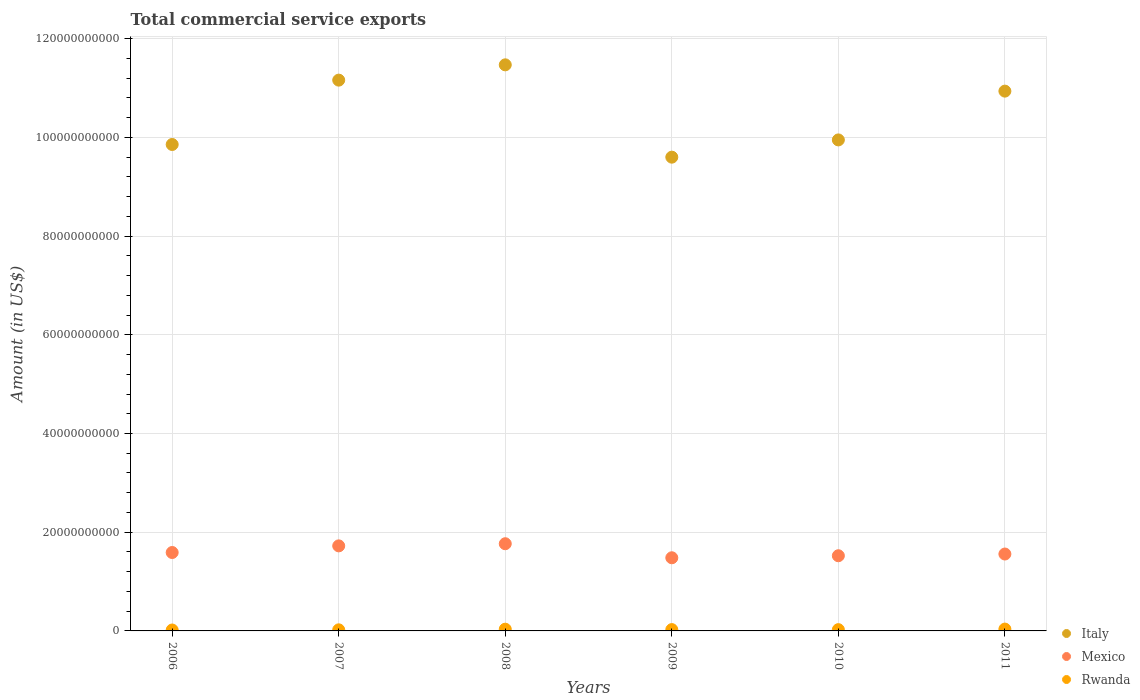What is the total commercial service exports in Mexico in 2010?
Provide a short and direct response. 1.52e+1. Across all years, what is the maximum total commercial service exports in Italy?
Make the answer very short. 1.15e+11. Across all years, what is the minimum total commercial service exports in Rwanda?
Make the answer very short. 1.87e+08. In which year was the total commercial service exports in Rwanda minimum?
Your response must be concise. 2006. What is the total total commercial service exports in Italy in the graph?
Keep it short and to the point. 6.30e+11. What is the difference between the total commercial service exports in Mexico in 2008 and that in 2009?
Your answer should be very brief. 2.85e+09. What is the difference between the total commercial service exports in Rwanda in 2010 and the total commercial service exports in Mexico in 2008?
Give a very brief answer. -1.74e+1. What is the average total commercial service exports in Italy per year?
Give a very brief answer. 1.05e+11. In the year 2009, what is the difference between the total commercial service exports in Rwanda and total commercial service exports in Italy?
Offer a terse response. -9.57e+1. What is the ratio of the total commercial service exports in Italy in 2006 to that in 2011?
Give a very brief answer. 0.9. What is the difference between the highest and the second highest total commercial service exports in Italy?
Provide a succinct answer. 3.10e+09. What is the difference between the highest and the lowest total commercial service exports in Rwanda?
Offer a terse response. 1.86e+08. Is the sum of the total commercial service exports in Mexico in 2008 and 2011 greater than the maximum total commercial service exports in Rwanda across all years?
Provide a short and direct response. Yes. Does the total commercial service exports in Rwanda monotonically increase over the years?
Give a very brief answer. No. Is the total commercial service exports in Rwanda strictly greater than the total commercial service exports in Mexico over the years?
Ensure brevity in your answer.  No. Is the total commercial service exports in Italy strictly less than the total commercial service exports in Mexico over the years?
Provide a short and direct response. No. How many dotlines are there?
Provide a succinct answer. 3. How many years are there in the graph?
Keep it short and to the point. 6. What is the difference between two consecutive major ticks on the Y-axis?
Your answer should be very brief. 2.00e+1. How many legend labels are there?
Ensure brevity in your answer.  3. What is the title of the graph?
Your answer should be compact. Total commercial service exports. Does "Kuwait" appear as one of the legend labels in the graph?
Provide a succinct answer. No. What is the Amount (in US$) in Italy in 2006?
Offer a terse response. 9.86e+1. What is the Amount (in US$) in Mexico in 2006?
Your answer should be compact. 1.59e+1. What is the Amount (in US$) in Rwanda in 2006?
Your answer should be very brief. 1.87e+08. What is the Amount (in US$) in Italy in 2007?
Make the answer very short. 1.12e+11. What is the Amount (in US$) of Mexico in 2007?
Provide a short and direct response. 1.72e+1. What is the Amount (in US$) of Rwanda in 2007?
Provide a succinct answer. 2.22e+08. What is the Amount (in US$) of Italy in 2008?
Provide a succinct answer. 1.15e+11. What is the Amount (in US$) of Mexico in 2008?
Offer a very short reply. 1.77e+1. What is the Amount (in US$) of Rwanda in 2008?
Ensure brevity in your answer.  3.51e+08. What is the Amount (in US$) in Italy in 2009?
Your answer should be very brief. 9.60e+1. What is the Amount (in US$) of Mexico in 2009?
Ensure brevity in your answer.  1.48e+1. What is the Amount (in US$) of Rwanda in 2009?
Ensure brevity in your answer.  2.69e+08. What is the Amount (in US$) in Italy in 2010?
Make the answer very short. 9.95e+1. What is the Amount (in US$) in Mexico in 2010?
Offer a very short reply. 1.52e+1. What is the Amount (in US$) of Rwanda in 2010?
Make the answer very short. 2.59e+08. What is the Amount (in US$) of Italy in 2011?
Give a very brief answer. 1.09e+11. What is the Amount (in US$) of Mexico in 2011?
Make the answer very short. 1.56e+1. What is the Amount (in US$) in Rwanda in 2011?
Provide a succinct answer. 3.73e+08. Across all years, what is the maximum Amount (in US$) in Italy?
Keep it short and to the point. 1.15e+11. Across all years, what is the maximum Amount (in US$) in Mexico?
Ensure brevity in your answer.  1.77e+1. Across all years, what is the maximum Amount (in US$) in Rwanda?
Provide a succinct answer. 3.73e+08. Across all years, what is the minimum Amount (in US$) of Italy?
Your answer should be compact. 9.60e+1. Across all years, what is the minimum Amount (in US$) of Mexico?
Offer a terse response. 1.48e+1. Across all years, what is the minimum Amount (in US$) of Rwanda?
Provide a succinct answer. 1.87e+08. What is the total Amount (in US$) of Italy in the graph?
Offer a terse response. 6.30e+11. What is the total Amount (in US$) in Mexico in the graph?
Offer a very short reply. 9.64e+1. What is the total Amount (in US$) of Rwanda in the graph?
Make the answer very short. 1.66e+09. What is the difference between the Amount (in US$) of Italy in 2006 and that in 2007?
Offer a terse response. -1.30e+1. What is the difference between the Amount (in US$) in Mexico in 2006 and that in 2007?
Provide a succinct answer. -1.35e+09. What is the difference between the Amount (in US$) in Rwanda in 2006 and that in 2007?
Offer a terse response. -3.54e+07. What is the difference between the Amount (in US$) of Italy in 2006 and that in 2008?
Offer a terse response. -1.61e+1. What is the difference between the Amount (in US$) in Mexico in 2006 and that in 2008?
Ensure brevity in your answer.  -1.78e+09. What is the difference between the Amount (in US$) in Rwanda in 2006 and that in 2008?
Offer a very short reply. -1.64e+08. What is the difference between the Amount (in US$) in Italy in 2006 and that in 2009?
Make the answer very short. 2.57e+09. What is the difference between the Amount (in US$) of Mexico in 2006 and that in 2009?
Keep it short and to the point. 1.07e+09. What is the difference between the Amount (in US$) of Rwanda in 2006 and that in 2009?
Your answer should be very brief. -8.28e+07. What is the difference between the Amount (in US$) of Italy in 2006 and that in 2010?
Ensure brevity in your answer.  -9.27e+08. What is the difference between the Amount (in US$) in Mexico in 2006 and that in 2010?
Give a very brief answer. 6.55e+08. What is the difference between the Amount (in US$) in Rwanda in 2006 and that in 2010?
Your response must be concise. -7.28e+07. What is the difference between the Amount (in US$) in Italy in 2006 and that in 2011?
Make the answer very short. -1.08e+1. What is the difference between the Amount (in US$) in Mexico in 2006 and that in 2011?
Ensure brevity in your answer.  3.07e+08. What is the difference between the Amount (in US$) of Rwanda in 2006 and that in 2011?
Your answer should be compact. -1.86e+08. What is the difference between the Amount (in US$) in Italy in 2007 and that in 2008?
Give a very brief answer. -3.10e+09. What is the difference between the Amount (in US$) of Mexico in 2007 and that in 2008?
Ensure brevity in your answer.  -4.34e+08. What is the difference between the Amount (in US$) of Rwanda in 2007 and that in 2008?
Provide a succinct answer. -1.29e+08. What is the difference between the Amount (in US$) in Italy in 2007 and that in 2009?
Keep it short and to the point. 1.56e+1. What is the difference between the Amount (in US$) of Mexico in 2007 and that in 2009?
Make the answer very short. 2.41e+09. What is the difference between the Amount (in US$) in Rwanda in 2007 and that in 2009?
Offer a terse response. -4.74e+07. What is the difference between the Amount (in US$) in Italy in 2007 and that in 2010?
Provide a succinct answer. 1.21e+1. What is the difference between the Amount (in US$) of Mexico in 2007 and that in 2010?
Your answer should be compact. 2.00e+09. What is the difference between the Amount (in US$) in Rwanda in 2007 and that in 2010?
Keep it short and to the point. -3.73e+07. What is the difference between the Amount (in US$) of Italy in 2007 and that in 2011?
Make the answer very short. 2.23e+09. What is the difference between the Amount (in US$) of Mexico in 2007 and that in 2011?
Provide a succinct answer. 1.65e+09. What is the difference between the Amount (in US$) in Rwanda in 2007 and that in 2011?
Keep it short and to the point. -1.51e+08. What is the difference between the Amount (in US$) in Italy in 2008 and that in 2009?
Your response must be concise. 1.87e+1. What is the difference between the Amount (in US$) of Mexico in 2008 and that in 2009?
Keep it short and to the point. 2.85e+09. What is the difference between the Amount (in US$) of Rwanda in 2008 and that in 2009?
Keep it short and to the point. 8.14e+07. What is the difference between the Amount (in US$) of Italy in 2008 and that in 2010?
Make the answer very short. 1.52e+1. What is the difference between the Amount (in US$) in Mexico in 2008 and that in 2010?
Offer a very short reply. 2.43e+09. What is the difference between the Amount (in US$) of Rwanda in 2008 and that in 2010?
Give a very brief answer. 9.14e+07. What is the difference between the Amount (in US$) of Italy in 2008 and that in 2011?
Offer a terse response. 5.33e+09. What is the difference between the Amount (in US$) of Mexico in 2008 and that in 2011?
Keep it short and to the point. 2.09e+09. What is the difference between the Amount (in US$) of Rwanda in 2008 and that in 2011?
Give a very brief answer. -2.21e+07. What is the difference between the Amount (in US$) of Italy in 2009 and that in 2010?
Provide a short and direct response. -3.49e+09. What is the difference between the Amount (in US$) of Mexico in 2009 and that in 2010?
Provide a short and direct response. -4.12e+08. What is the difference between the Amount (in US$) of Rwanda in 2009 and that in 2010?
Provide a succinct answer. 1.00e+07. What is the difference between the Amount (in US$) in Italy in 2009 and that in 2011?
Keep it short and to the point. -1.34e+1. What is the difference between the Amount (in US$) of Mexico in 2009 and that in 2011?
Give a very brief answer. -7.60e+08. What is the difference between the Amount (in US$) of Rwanda in 2009 and that in 2011?
Your answer should be compact. -1.04e+08. What is the difference between the Amount (in US$) of Italy in 2010 and that in 2011?
Provide a succinct answer. -9.89e+09. What is the difference between the Amount (in US$) in Mexico in 2010 and that in 2011?
Provide a succinct answer. -3.48e+08. What is the difference between the Amount (in US$) in Rwanda in 2010 and that in 2011?
Ensure brevity in your answer.  -1.14e+08. What is the difference between the Amount (in US$) of Italy in 2006 and the Amount (in US$) of Mexico in 2007?
Provide a short and direct response. 8.13e+1. What is the difference between the Amount (in US$) in Italy in 2006 and the Amount (in US$) in Rwanda in 2007?
Keep it short and to the point. 9.83e+1. What is the difference between the Amount (in US$) of Mexico in 2006 and the Amount (in US$) of Rwanda in 2007?
Your answer should be very brief. 1.57e+1. What is the difference between the Amount (in US$) of Italy in 2006 and the Amount (in US$) of Mexico in 2008?
Keep it short and to the point. 8.09e+1. What is the difference between the Amount (in US$) in Italy in 2006 and the Amount (in US$) in Rwanda in 2008?
Ensure brevity in your answer.  9.82e+1. What is the difference between the Amount (in US$) in Mexico in 2006 and the Amount (in US$) in Rwanda in 2008?
Your answer should be compact. 1.55e+1. What is the difference between the Amount (in US$) in Italy in 2006 and the Amount (in US$) in Mexico in 2009?
Your response must be concise. 8.37e+1. What is the difference between the Amount (in US$) of Italy in 2006 and the Amount (in US$) of Rwanda in 2009?
Give a very brief answer. 9.83e+1. What is the difference between the Amount (in US$) in Mexico in 2006 and the Amount (in US$) in Rwanda in 2009?
Keep it short and to the point. 1.56e+1. What is the difference between the Amount (in US$) of Italy in 2006 and the Amount (in US$) of Mexico in 2010?
Your answer should be compact. 8.33e+1. What is the difference between the Amount (in US$) in Italy in 2006 and the Amount (in US$) in Rwanda in 2010?
Offer a terse response. 9.83e+1. What is the difference between the Amount (in US$) of Mexico in 2006 and the Amount (in US$) of Rwanda in 2010?
Provide a succinct answer. 1.56e+1. What is the difference between the Amount (in US$) in Italy in 2006 and the Amount (in US$) in Mexico in 2011?
Your answer should be compact. 8.30e+1. What is the difference between the Amount (in US$) of Italy in 2006 and the Amount (in US$) of Rwanda in 2011?
Provide a succinct answer. 9.82e+1. What is the difference between the Amount (in US$) of Mexico in 2006 and the Amount (in US$) of Rwanda in 2011?
Your response must be concise. 1.55e+1. What is the difference between the Amount (in US$) of Italy in 2007 and the Amount (in US$) of Mexico in 2008?
Offer a terse response. 9.39e+1. What is the difference between the Amount (in US$) of Italy in 2007 and the Amount (in US$) of Rwanda in 2008?
Make the answer very short. 1.11e+11. What is the difference between the Amount (in US$) in Mexico in 2007 and the Amount (in US$) in Rwanda in 2008?
Provide a succinct answer. 1.69e+1. What is the difference between the Amount (in US$) in Italy in 2007 and the Amount (in US$) in Mexico in 2009?
Give a very brief answer. 9.68e+1. What is the difference between the Amount (in US$) in Italy in 2007 and the Amount (in US$) in Rwanda in 2009?
Give a very brief answer. 1.11e+11. What is the difference between the Amount (in US$) in Mexico in 2007 and the Amount (in US$) in Rwanda in 2009?
Offer a terse response. 1.70e+1. What is the difference between the Amount (in US$) in Italy in 2007 and the Amount (in US$) in Mexico in 2010?
Provide a succinct answer. 9.64e+1. What is the difference between the Amount (in US$) in Italy in 2007 and the Amount (in US$) in Rwanda in 2010?
Ensure brevity in your answer.  1.11e+11. What is the difference between the Amount (in US$) of Mexico in 2007 and the Amount (in US$) of Rwanda in 2010?
Your response must be concise. 1.70e+1. What is the difference between the Amount (in US$) of Italy in 2007 and the Amount (in US$) of Mexico in 2011?
Provide a succinct answer. 9.60e+1. What is the difference between the Amount (in US$) of Italy in 2007 and the Amount (in US$) of Rwanda in 2011?
Give a very brief answer. 1.11e+11. What is the difference between the Amount (in US$) in Mexico in 2007 and the Amount (in US$) in Rwanda in 2011?
Offer a very short reply. 1.69e+1. What is the difference between the Amount (in US$) in Italy in 2008 and the Amount (in US$) in Mexico in 2009?
Keep it short and to the point. 9.99e+1. What is the difference between the Amount (in US$) of Italy in 2008 and the Amount (in US$) of Rwanda in 2009?
Your answer should be very brief. 1.14e+11. What is the difference between the Amount (in US$) of Mexico in 2008 and the Amount (in US$) of Rwanda in 2009?
Offer a very short reply. 1.74e+1. What is the difference between the Amount (in US$) of Italy in 2008 and the Amount (in US$) of Mexico in 2010?
Your answer should be compact. 9.95e+1. What is the difference between the Amount (in US$) of Italy in 2008 and the Amount (in US$) of Rwanda in 2010?
Provide a short and direct response. 1.14e+11. What is the difference between the Amount (in US$) of Mexico in 2008 and the Amount (in US$) of Rwanda in 2010?
Your response must be concise. 1.74e+1. What is the difference between the Amount (in US$) in Italy in 2008 and the Amount (in US$) in Mexico in 2011?
Provide a succinct answer. 9.91e+1. What is the difference between the Amount (in US$) in Italy in 2008 and the Amount (in US$) in Rwanda in 2011?
Your answer should be very brief. 1.14e+11. What is the difference between the Amount (in US$) in Mexico in 2008 and the Amount (in US$) in Rwanda in 2011?
Provide a short and direct response. 1.73e+1. What is the difference between the Amount (in US$) in Italy in 2009 and the Amount (in US$) in Mexico in 2010?
Provide a short and direct response. 8.08e+1. What is the difference between the Amount (in US$) in Italy in 2009 and the Amount (in US$) in Rwanda in 2010?
Your answer should be compact. 9.57e+1. What is the difference between the Amount (in US$) of Mexico in 2009 and the Amount (in US$) of Rwanda in 2010?
Provide a short and direct response. 1.46e+1. What is the difference between the Amount (in US$) in Italy in 2009 and the Amount (in US$) in Mexico in 2011?
Your answer should be very brief. 8.04e+1. What is the difference between the Amount (in US$) of Italy in 2009 and the Amount (in US$) of Rwanda in 2011?
Keep it short and to the point. 9.56e+1. What is the difference between the Amount (in US$) in Mexico in 2009 and the Amount (in US$) in Rwanda in 2011?
Provide a short and direct response. 1.44e+1. What is the difference between the Amount (in US$) in Italy in 2010 and the Amount (in US$) in Mexico in 2011?
Offer a very short reply. 8.39e+1. What is the difference between the Amount (in US$) in Italy in 2010 and the Amount (in US$) in Rwanda in 2011?
Your answer should be very brief. 9.91e+1. What is the difference between the Amount (in US$) of Mexico in 2010 and the Amount (in US$) of Rwanda in 2011?
Your answer should be compact. 1.49e+1. What is the average Amount (in US$) of Italy per year?
Your response must be concise. 1.05e+11. What is the average Amount (in US$) in Mexico per year?
Your answer should be very brief. 1.61e+1. What is the average Amount (in US$) in Rwanda per year?
Give a very brief answer. 2.77e+08. In the year 2006, what is the difference between the Amount (in US$) in Italy and Amount (in US$) in Mexico?
Ensure brevity in your answer.  8.27e+1. In the year 2006, what is the difference between the Amount (in US$) in Italy and Amount (in US$) in Rwanda?
Make the answer very short. 9.84e+1. In the year 2006, what is the difference between the Amount (in US$) of Mexico and Amount (in US$) of Rwanda?
Provide a succinct answer. 1.57e+1. In the year 2007, what is the difference between the Amount (in US$) of Italy and Amount (in US$) of Mexico?
Ensure brevity in your answer.  9.44e+1. In the year 2007, what is the difference between the Amount (in US$) of Italy and Amount (in US$) of Rwanda?
Give a very brief answer. 1.11e+11. In the year 2007, what is the difference between the Amount (in US$) of Mexico and Amount (in US$) of Rwanda?
Keep it short and to the point. 1.70e+1. In the year 2008, what is the difference between the Amount (in US$) of Italy and Amount (in US$) of Mexico?
Make the answer very short. 9.70e+1. In the year 2008, what is the difference between the Amount (in US$) of Italy and Amount (in US$) of Rwanda?
Provide a succinct answer. 1.14e+11. In the year 2008, what is the difference between the Amount (in US$) of Mexico and Amount (in US$) of Rwanda?
Your response must be concise. 1.73e+1. In the year 2009, what is the difference between the Amount (in US$) in Italy and Amount (in US$) in Mexico?
Give a very brief answer. 8.12e+1. In the year 2009, what is the difference between the Amount (in US$) in Italy and Amount (in US$) in Rwanda?
Your response must be concise. 9.57e+1. In the year 2009, what is the difference between the Amount (in US$) in Mexico and Amount (in US$) in Rwanda?
Make the answer very short. 1.46e+1. In the year 2010, what is the difference between the Amount (in US$) of Italy and Amount (in US$) of Mexico?
Your answer should be compact. 8.43e+1. In the year 2010, what is the difference between the Amount (in US$) in Italy and Amount (in US$) in Rwanda?
Make the answer very short. 9.92e+1. In the year 2010, what is the difference between the Amount (in US$) in Mexico and Amount (in US$) in Rwanda?
Provide a short and direct response. 1.50e+1. In the year 2011, what is the difference between the Amount (in US$) of Italy and Amount (in US$) of Mexico?
Keep it short and to the point. 9.38e+1. In the year 2011, what is the difference between the Amount (in US$) in Italy and Amount (in US$) in Rwanda?
Provide a short and direct response. 1.09e+11. In the year 2011, what is the difference between the Amount (in US$) of Mexico and Amount (in US$) of Rwanda?
Your response must be concise. 1.52e+1. What is the ratio of the Amount (in US$) of Italy in 2006 to that in 2007?
Your answer should be very brief. 0.88. What is the ratio of the Amount (in US$) of Mexico in 2006 to that in 2007?
Offer a very short reply. 0.92. What is the ratio of the Amount (in US$) of Rwanda in 2006 to that in 2007?
Keep it short and to the point. 0.84. What is the ratio of the Amount (in US$) in Italy in 2006 to that in 2008?
Offer a very short reply. 0.86. What is the ratio of the Amount (in US$) of Mexico in 2006 to that in 2008?
Give a very brief answer. 0.9. What is the ratio of the Amount (in US$) in Rwanda in 2006 to that in 2008?
Your response must be concise. 0.53. What is the ratio of the Amount (in US$) of Italy in 2006 to that in 2009?
Ensure brevity in your answer.  1.03. What is the ratio of the Amount (in US$) of Mexico in 2006 to that in 2009?
Your response must be concise. 1.07. What is the ratio of the Amount (in US$) of Rwanda in 2006 to that in 2009?
Ensure brevity in your answer.  0.69. What is the ratio of the Amount (in US$) of Italy in 2006 to that in 2010?
Provide a short and direct response. 0.99. What is the ratio of the Amount (in US$) of Mexico in 2006 to that in 2010?
Offer a very short reply. 1.04. What is the ratio of the Amount (in US$) in Rwanda in 2006 to that in 2010?
Keep it short and to the point. 0.72. What is the ratio of the Amount (in US$) in Italy in 2006 to that in 2011?
Provide a short and direct response. 0.9. What is the ratio of the Amount (in US$) in Mexico in 2006 to that in 2011?
Provide a succinct answer. 1.02. What is the ratio of the Amount (in US$) in Rwanda in 2006 to that in 2011?
Provide a succinct answer. 0.5. What is the ratio of the Amount (in US$) of Italy in 2007 to that in 2008?
Make the answer very short. 0.97. What is the ratio of the Amount (in US$) of Mexico in 2007 to that in 2008?
Your response must be concise. 0.98. What is the ratio of the Amount (in US$) in Rwanda in 2007 to that in 2008?
Keep it short and to the point. 0.63. What is the ratio of the Amount (in US$) in Italy in 2007 to that in 2009?
Provide a short and direct response. 1.16. What is the ratio of the Amount (in US$) in Mexico in 2007 to that in 2009?
Ensure brevity in your answer.  1.16. What is the ratio of the Amount (in US$) in Rwanda in 2007 to that in 2009?
Ensure brevity in your answer.  0.82. What is the ratio of the Amount (in US$) of Italy in 2007 to that in 2010?
Offer a terse response. 1.12. What is the ratio of the Amount (in US$) in Mexico in 2007 to that in 2010?
Keep it short and to the point. 1.13. What is the ratio of the Amount (in US$) of Rwanda in 2007 to that in 2010?
Your answer should be compact. 0.86. What is the ratio of the Amount (in US$) in Italy in 2007 to that in 2011?
Make the answer very short. 1.02. What is the ratio of the Amount (in US$) of Mexico in 2007 to that in 2011?
Offer a terse response. 1.11. What is the ratio of the Amount (in US$) of Rwanda in 2007 to that in 2011?
Provide a succinct answer. 0.6. What is the ratio of the Amount (in US$) of Italy in 2008 to that in 2009?
Your response must be concise. 1.19. What is the ratio of the Amount (in US$) in Mexico in 2008 to that in 2009?
Provide a short and direct response. 1.19. What is the ratio of the Amount (in US$) in Rwanda in 2008 to that in 2009?
Your response must be concise. 1.3. What is the ratio of the Amount (in US$) in Italy in 2008 to that in 2010?
Your answer should be compact. 1.15. What is the ratio of the Amount (in US$) in Mexico in 2008 to that in 2010?
Give a very brief answer. 1.16. What is the ratio of the Amount (in US$) of Rwanda in 2008 to that in 2010?
Offer a very short reply. 1.35. What is the ratio of the Amount (in US$) of Italy in 2008 to that in 2011?
Provide a succinct answer. 1.05. What is the ratio of the Amount (in US$) of Mexico in 2008 to that in 2011?
Make the answer very short. 1.13. What is the ratio of the Amount (in US$) in Rwanda in 2008 to that in 2011?
Provide a short and direct response. 0.94. What is the ratio of the Amount (in US$) in Italy in 2009 to that in 2010?
Provide a short and direct response. 0.96. What is the ratio of the Amount (in US$) of Rwanda in 2009 to that in 2010?
Keep it short and to the point. 1.04. What is the ratio of the Amount (in US$) of Italy in 2009 to that in 2011?
Make the answer very short. 0.88. What is the ratio of the Amount (in US$) of Mexico in 2009 to that in 2011?
Your answer should be compact. 0.95. What is the ratio of the Amount (in US$) in Rwanda in 2009 to that in 2011?
Provide a short and direct response. 0.72. What is the ratio of the Amount (in US$) in Italy in 2010 to that in 2011?
Provide a short and direct response. 0.91. What is the ratio of the Amount (in US$) of Mexico in 2010 to that in 2011?
Ensure brevity in your answer.  0.98. What is the ratio of the Amount (in US$) in Rwanda in 2010 to that in 2011?
Your response must be concise. 0.7. What is the difference between the highest and the second highest Amount (in US$) of Italy?
Make the answer very short. 3.10e+09. What is the difference between the highest and the second highest Amount (in US$) in Mexico?
Ensure brevity in your answer.  4.34e+08. What is the difference between the highest and the second highest Amount (in US$) of Rwanda?
Provide a succinct answer. 2.21e+07. What is the difference between the highest and the lowest Amount (in US$) in Italy?
Provide a short and direct response. 1.87e+1. What is the difference between the highest and the lowest Amount (in US$) of Mexico?
Make the answer very short. 2.85e+09. What is the difference between the highest and the lowest Amount (in US$) in Rwanda?
Offer a very short reply. 1.86e+08. 